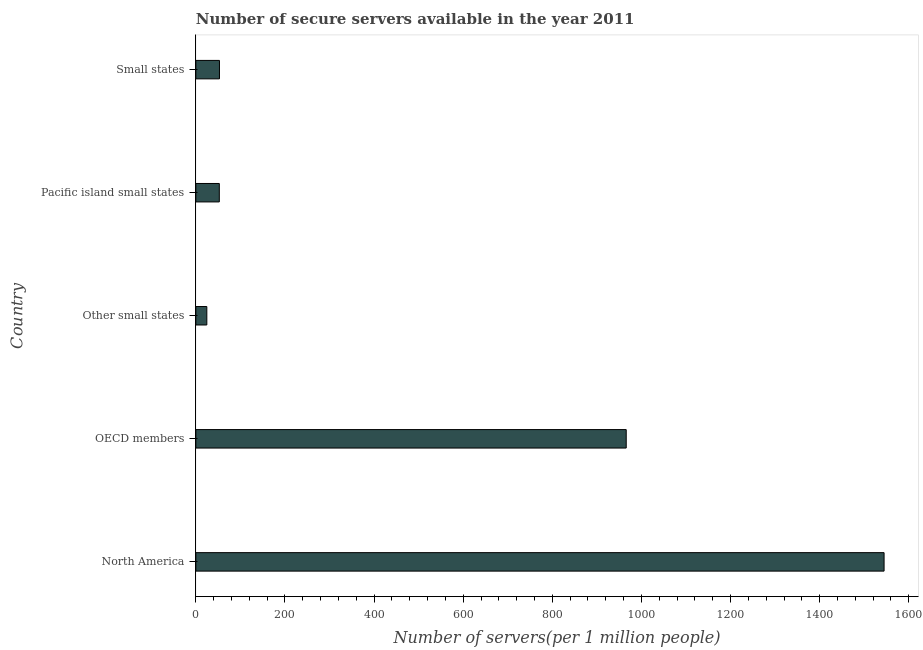Does the graph contain any zero values?
Your response must be concise. No. What is the title of the graph?
Keep it short and to the point. Number of secure servers available in the year 2011. What is the label or title of the X-axis?
Provide a succinct answer. Number of servers(per 1 million people). What is the label or title of the Y-axis?
Your answer should be very brief. Country. What is the number of secure internet servers in Small states?
Offer a terse response. 53.05. Across all countries, what is the maximum number of secure internet servers?
Keep it short and to the point. 1544.53. Across all countries, what is the minimum number of secure internet servers?
Your response must be concise. 24.67. In which country was the number of secure internet servers minimum?
Ensure brevity in your answer.  Other small states. What is the sum of the number of secure internet servers?
Your answer should be very brief. 2640.81. What is the difference between the number of secure internet servers in OECD members and Small states?
Offer a very short reply. 912.82. What is the average number of secure internet servers per country?
Give a very brief answer. 528.16. What is the median number of secure internet servers?
Your answer should be compact. 53.05. In how many countries, is the number of secure internet servers greater than 320 ?
Ensure brevity in your answer.  2. What is the ratio of the number of secure internet servers in North America to that in Small states?
Provide a short and direct response. 29.12. Is the difference between the number of secure internet servers in OECD members and Other small states greater than the difference between any two countries?
Offer a terse response. No. What is the difference between the highest and the second highest number of secure internet servers?
Give a very brief answer. 578.67. What is the difference between the highest and the lowest number of secure internet servers?
Your response must be concise. 1519.86. In how many countries, is the number of secure internet servers greater than the average number of secure internet servers taken over all countries?
Offer a terse response. 2. How many bars are there?
Offer a terse response. 5. What is the difference between two consecutive major ticks on the X-axis?
Provide a succinct answer. 200. Are the values on the major ticks of X-axis written in scientific E-notation?
Your answer should be compact. No. What is the Number of servers(per 1 million people) in North America?
Your response must be concise. 1544.53. What is the Number of servers(per 1 million people) in OECD members?
Your response must be concise. 965.86. What is the Number of servers(per 1 million people) of Other small states?
Your answer should be compact. 24.67. What is the Number of servers(per 1 million people) of Pacific island small states?
Ensure brevity in your answer.  52.7. What is the Number of servers(per 1 million people) of Small states?
Give a very brief answer. 53.05. What is the difference between the Number of servers(per 1 million people) in North America and OECD members?
Provide a short and direct response. 578.67. What is the difference between the Number of servers(per 1 million people) in North America and Other small states?
Give a very brief answer. 1519.86. What is the difference between the Number of servers(per 1 million people) in North America and Pacific island small states?
Provide a short and direct response. 1491.83. What is the difference between the Number of servers(per 1 million people) in North America and Small states?
Offer a terse response. 1491.49. What is the difference between the Number of servers(per 1 million people) in OECD members and Other small states?
Your response must be concise. 941.19. What is the difference between the Number of servers(per 1 million people) in OECD members and Pacific island small states?
Make the answer very short. 913.16. What is the difference between the Number of servers(per 1 million people) in OECD members and Small states?
Give a very brief answer. 912.82. What is the difference between the Number of servers(per 1 million people) in Other small states and Pacific island small states?
Make the answer very short. -28.03. What is the difference between the Number of servers(per 1 million people) in Other small states and Small states?
Your response must be concise. -28.37. What is the difference between the Number of servers(per 1 million people) in Pacific island small states and Small states?
Your response must be concise. -0.34. What is the ratio of the Number of servers(per 1 million people) in North America to that in OECD members?
Provide a short and direct response. 1.6. What is the ratio of the Number of servers(per 1 million people) in North America to that in Other small states?
Your answer should be compact. 62.6. What is the ratio of the Number of servers(per 1 million people) in North America to that in Pacific island small states?
Offer a very short reply. 29.31. What is the ratio of the Number of servers(per 1 million people) in North America to that in Small states?
Ensure brevity in your answer.  29.12. What is the ratio of the Number of servers(per 1 million people) in OECD members to that in Other small states?
Keep it short and to the point. 39.15. What is the ratio of the Number of servers(per 1 million people) in OECD members to that in Pacific island small states?
Ensure brevity in your answer.  18.33. What is the ratio of the Number of servers(per 1 million people) in OECD members to that in Small states?
Keep it short and to the point. 18.21. What is the ratio of the Number of servers(per 1 million people) in Other small states to that in Pacific island small states?
Your answer should be very brief. 0.47. What is the ratio of the Number of servers(per 1 million people) in Other small states to that in Small states?
Provide a short and direct response. 0.47. What is the ratio of the Number of servers(per 1 million people) in Pacific island small states to that in Small states?
Offer a very short reply. 0.99. 